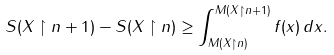<formula> <loc_0><loc_0><loc_500><loc_500>S ( X \restriction n + 1 ) - S ( X \restriction n ) \geq \int _ { M ( X \restriction n ) } ^ { M ( X \restriction n + 1 ) } f ( x ) \, d x .</formula> 